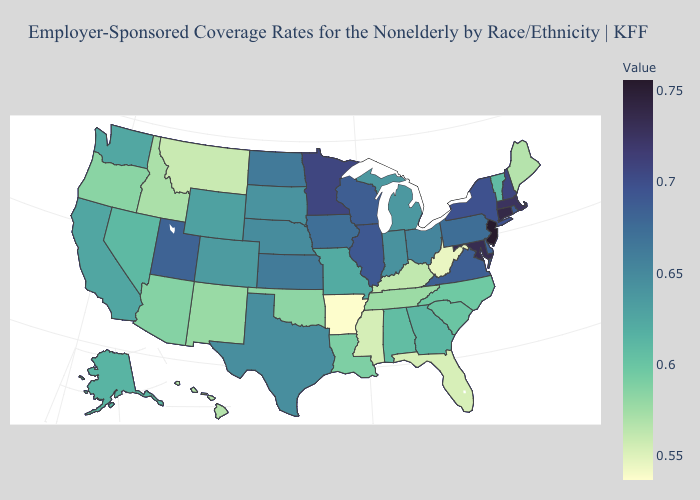Does Missouri have the lowest value in the MidWest?
Write a very short answer. Yes. Does Utah have the highest value in the USA?
Short answer required. No. Among the states that border Kentucky , does West Virginia have the lowest value?
Be succinct. Yes. Among the states that border New Jersey , which have the lowest value?
Short answer required. Pennsylvania. Does Arkansas have the lowest value in the USA?
Give a very brief answer. Yes. Which states hav the highest value in the MidWest?
Quick response, please. Minnesota. 